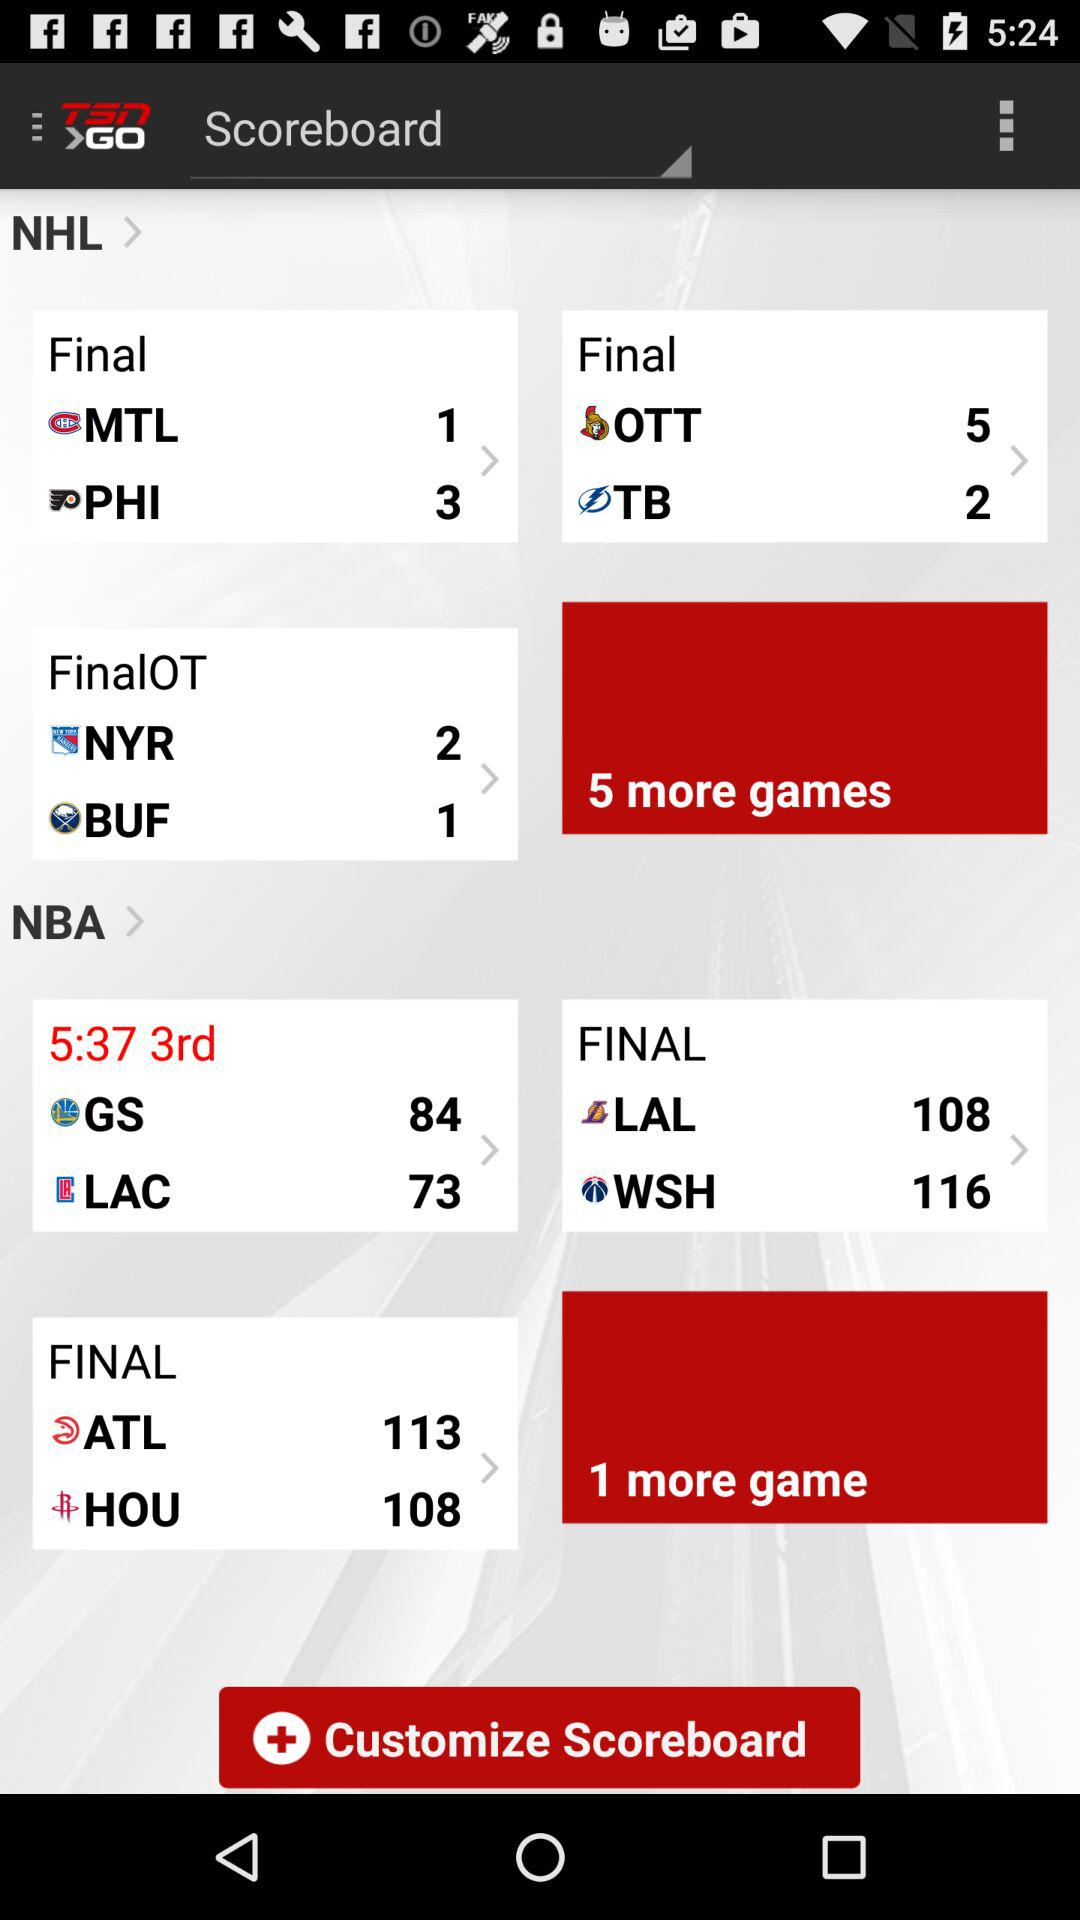What is the final score between ATL and HOU? The final scores between ATL and HOU are 113 and 108, respectively. 